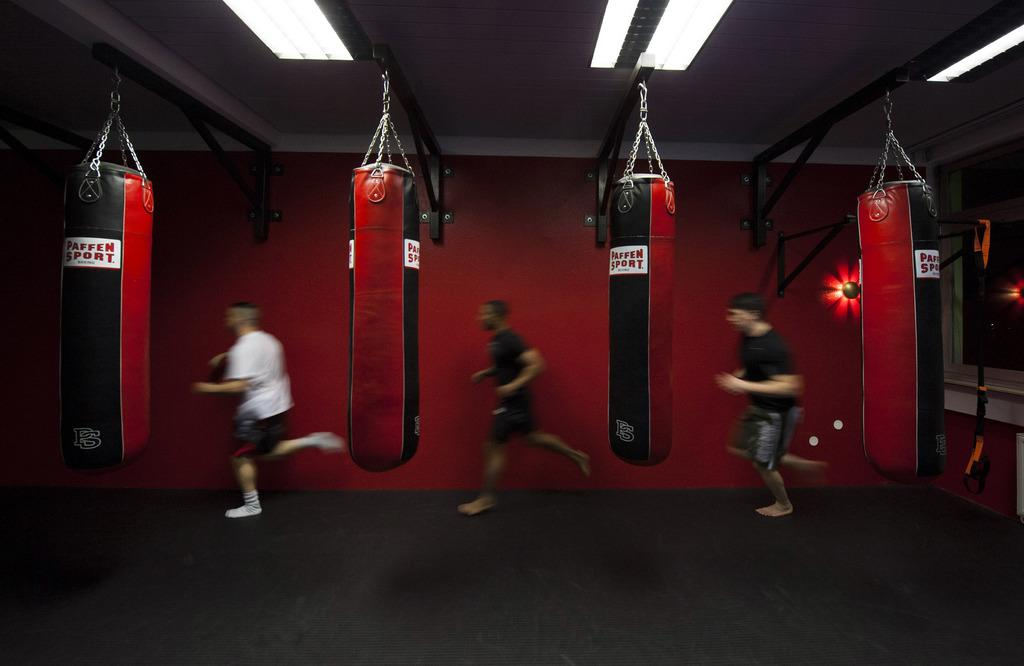How many people are in the image? There are people in the image, but the exact number is not specified. What type of lighting is present in the image? There are ceiling lights in the image. What are the sandbags used for in the image? The purpose of the sandbags in the image is not specified. What are the chains attached to in the image? The chains are visible in the image, but their attachment points are not specified. What are the rods used for in the image? The purpose of the rods in the image is not specified. What can be seen through the window in the image? The view through the window in the image is not specified. What type of flooring is present in the image? The floor has a carpet in the image. What type of cake is being served in the image? There is no mention of cake in the image. 